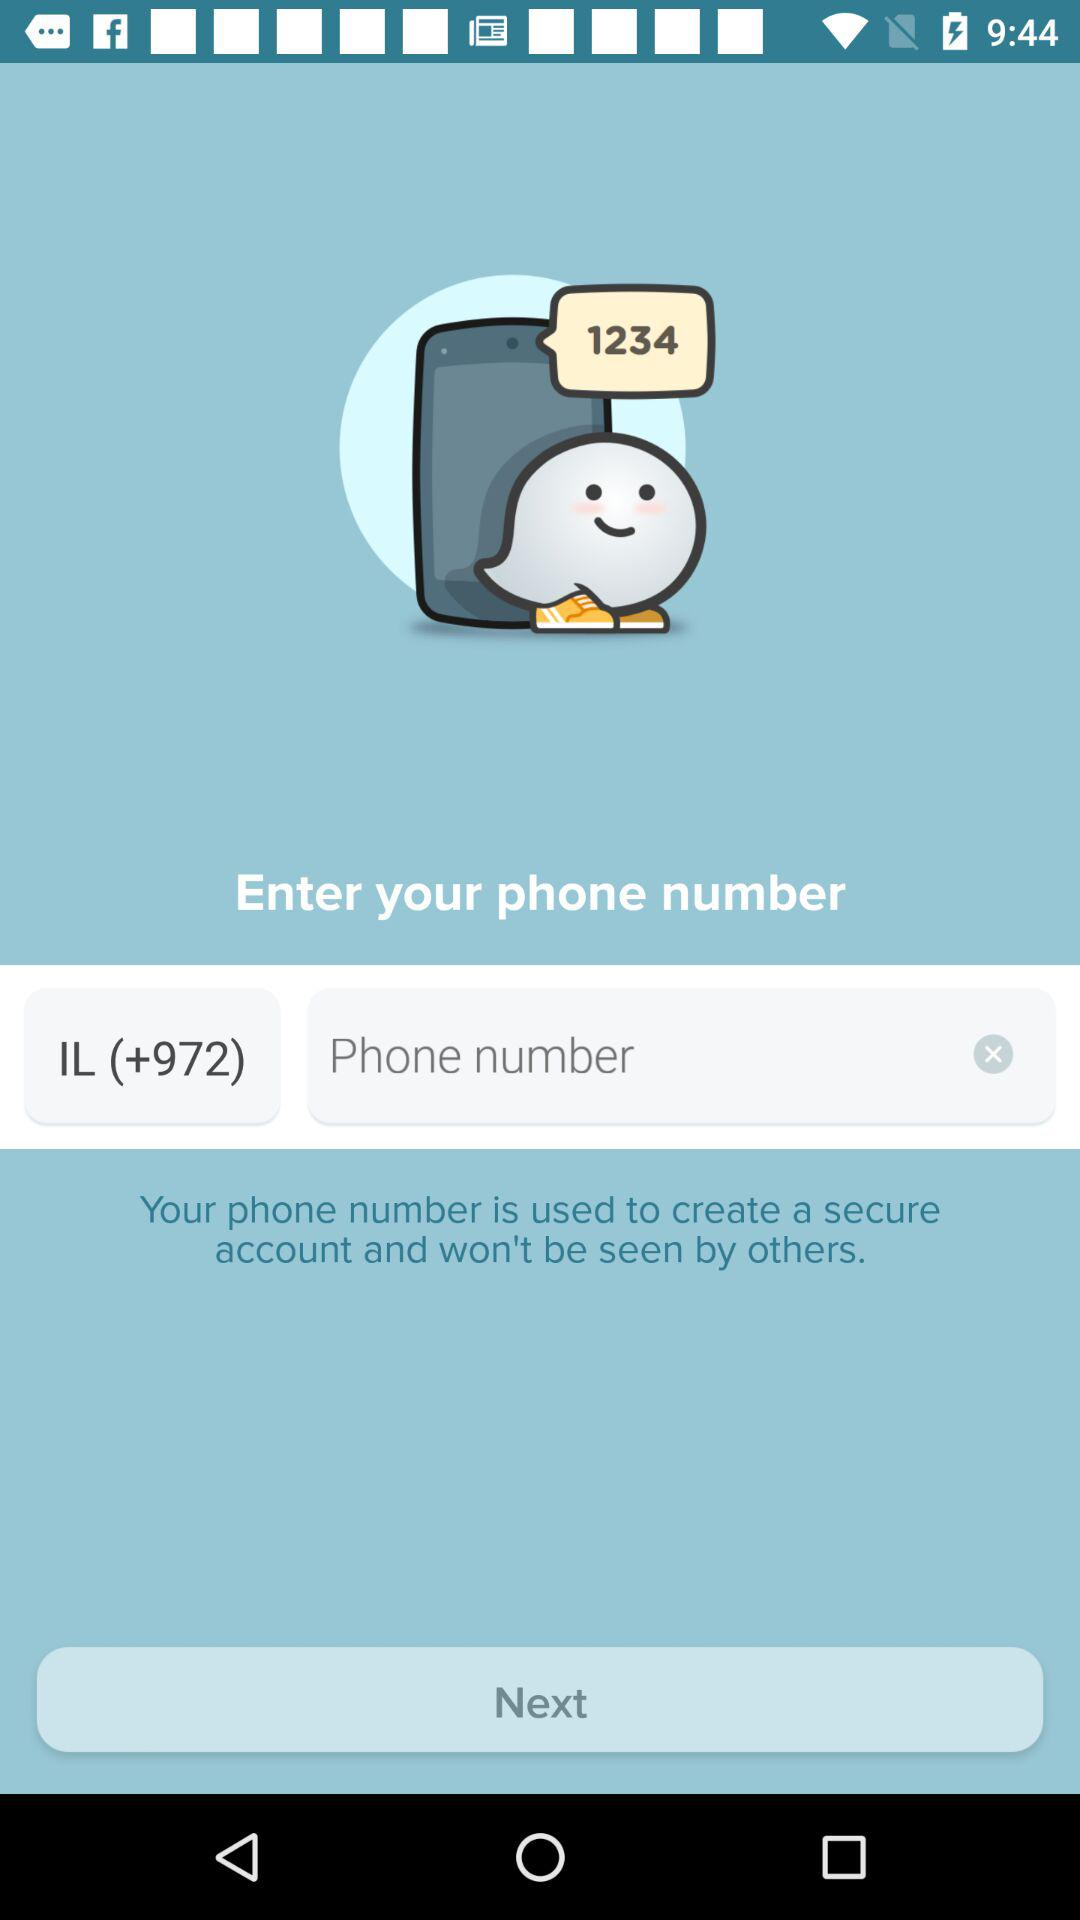How many text inputs are there that contain text?
Answer the question using a single word or phrase. 2 